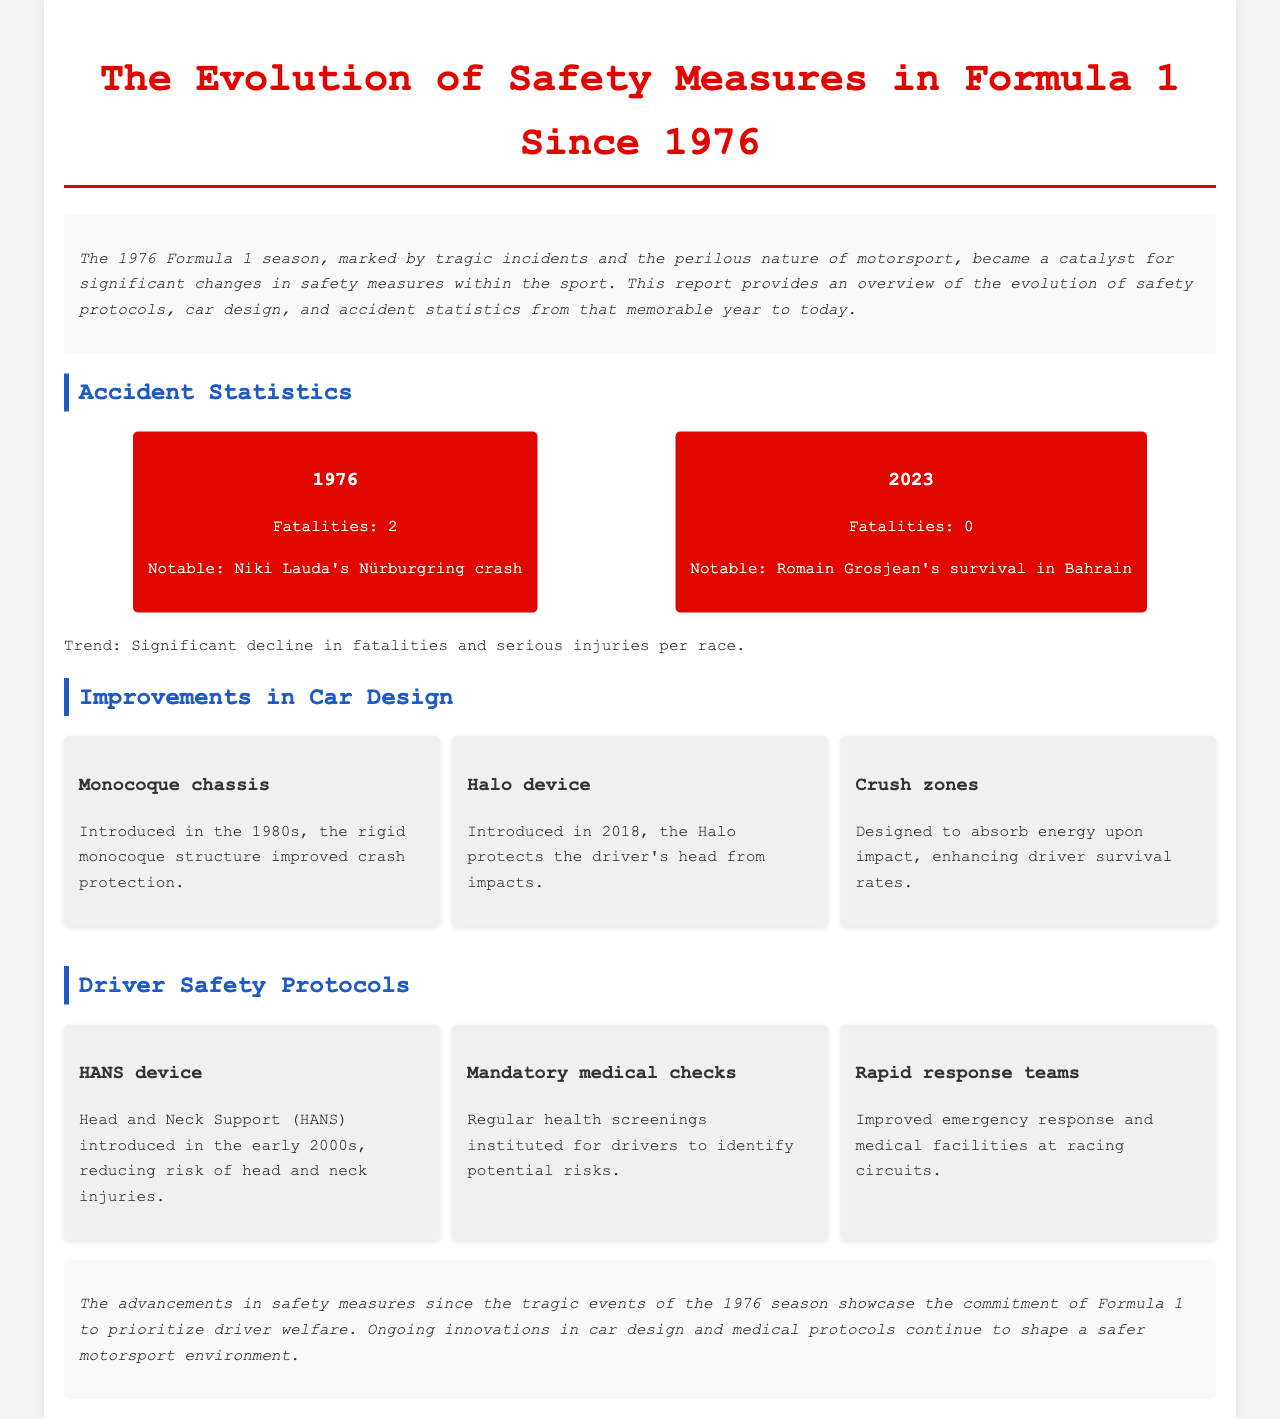What were the fatalities in the 1976 season? The fatalities in the 1976 season were highlighted in the accident statistics section of the report, which states there were 2.
Answer: 2 What notable event is associated with the 1976 fatalities? The report mentions Niki Lauda's Nürburgring crash as a notable event linked to the fatalities in 1976.
Answer: Niki Lauda's Nürburgring crash What is the trend in fatalities from 1976 to 2023? The document indicates a significant decline in fatalities and serious injuries per race from 1976 to 2023.
Answer: Significant decline What year was the Halo device introduced? The introduction year of the Halo device is provided in the section about car design improvements, specifically stating it was introduced in 2018.
Answer: 2018 What type of chassis was introduced in the 1980s? The report mentions that the monocoque chassis was introduced in the 1980s, improving crash protection.
Answer: Monocoque chassis What does the HANS device reduce the risk of? The report specifies that the HANS device reduces the risk of head and neck injuries.
Answer: Head and neck injuries How many innovations in car design are listed in the report? The report lists three innovations in car design, indicating their significance in safety measures.
Answer: 3 What is the purpose of crush zones in car design? The document explains that crush zones are designed to absorb energy upon impact, thus enhancing driver survival rates.
Answer: Absorb energy What kind of response teams are improved in Formula 1 since 1976? The report identifies that rapid response teams for emergencies have been improved at racing circuits since 1976.
Answer: Rapid response teams 